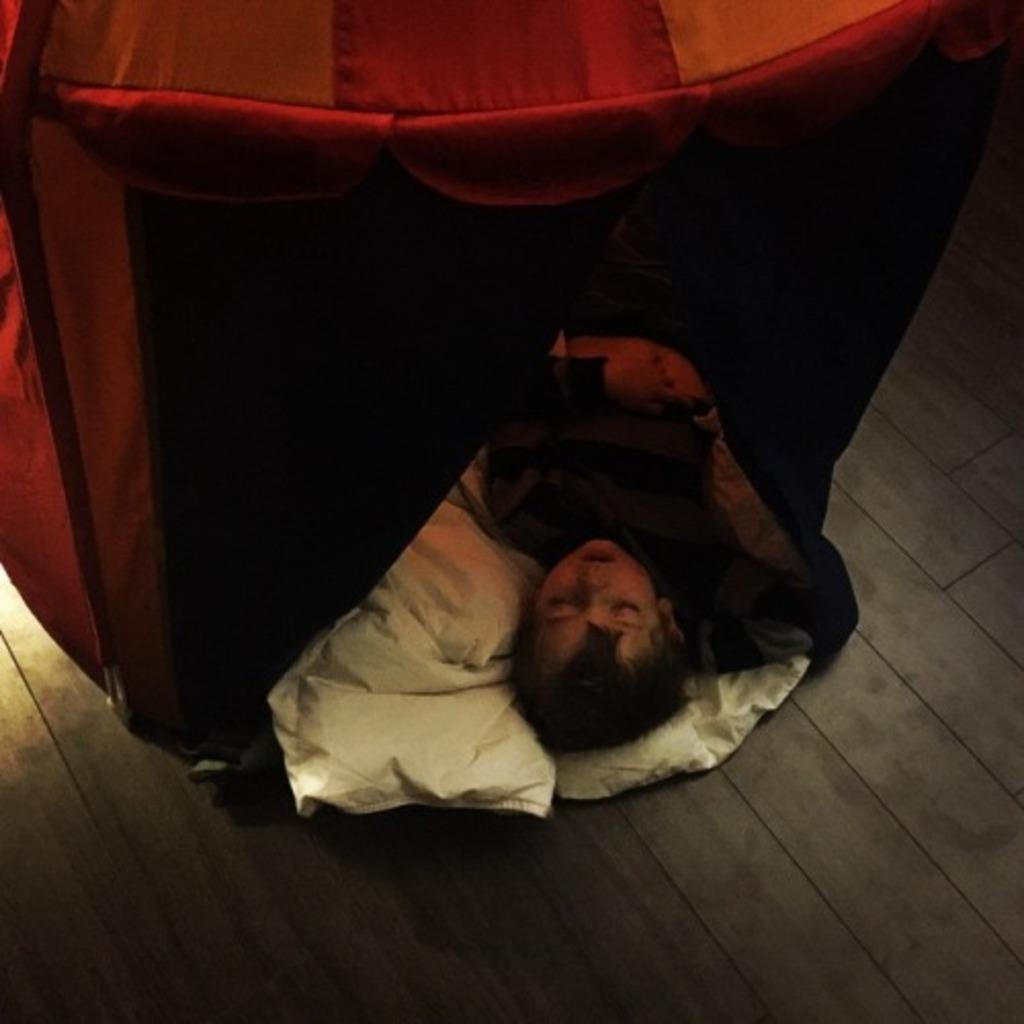What is the person in the image doing? The person is sleeping on the floor in the image. What can be seen at the bottom of the image? There is a white cloth at the bottom of the image. What is the color and location of the tent in the image? The tent is red-colored and located in the front of the image. What is the material of the floor in the image? The floor is made of wood. What type of metal drink is being served on the top of the tent in the image? There is no metal drink or any drink visible in the image, and the tent does not have anything on top of it. 